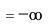<formula> <loc_0><loc_0><loc_500><loc_500>= - \infty</formula> 